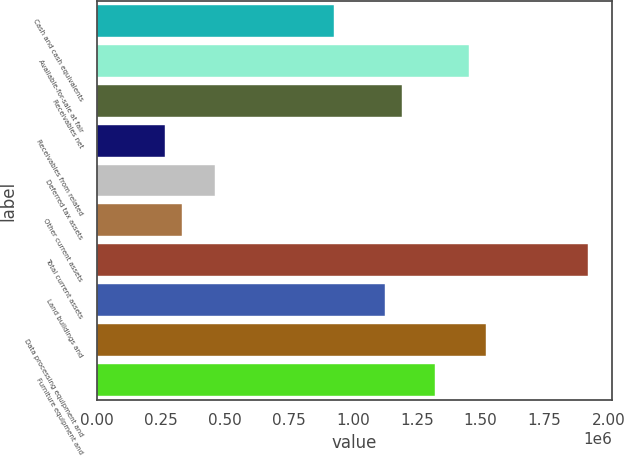Convert chart. <chart><loc_0><loc_0><loc_500><loc_500><bar_chart><fcel>Cash and cash equivalents<fcel>Available-for-sale at fair<fcel>Receivables net<fcel>Receivables from related<fcel>Deferred tax assets<fcel>Other current assets<fcel>Total current assets<fcel>Land buildings and<fcel>Data processing equipment and<fcel>Furniture equipment and<nl><fcel>926391<fcel>1.45517e+06<fcel>1.19078e+06<fcel>265419<fcel>463710<fcel>331516<fcel>1.91785e+06<fcel>1.12468e+06<fcel>1.52127e+06<fcel>1.32297e+06<nl></chart> 